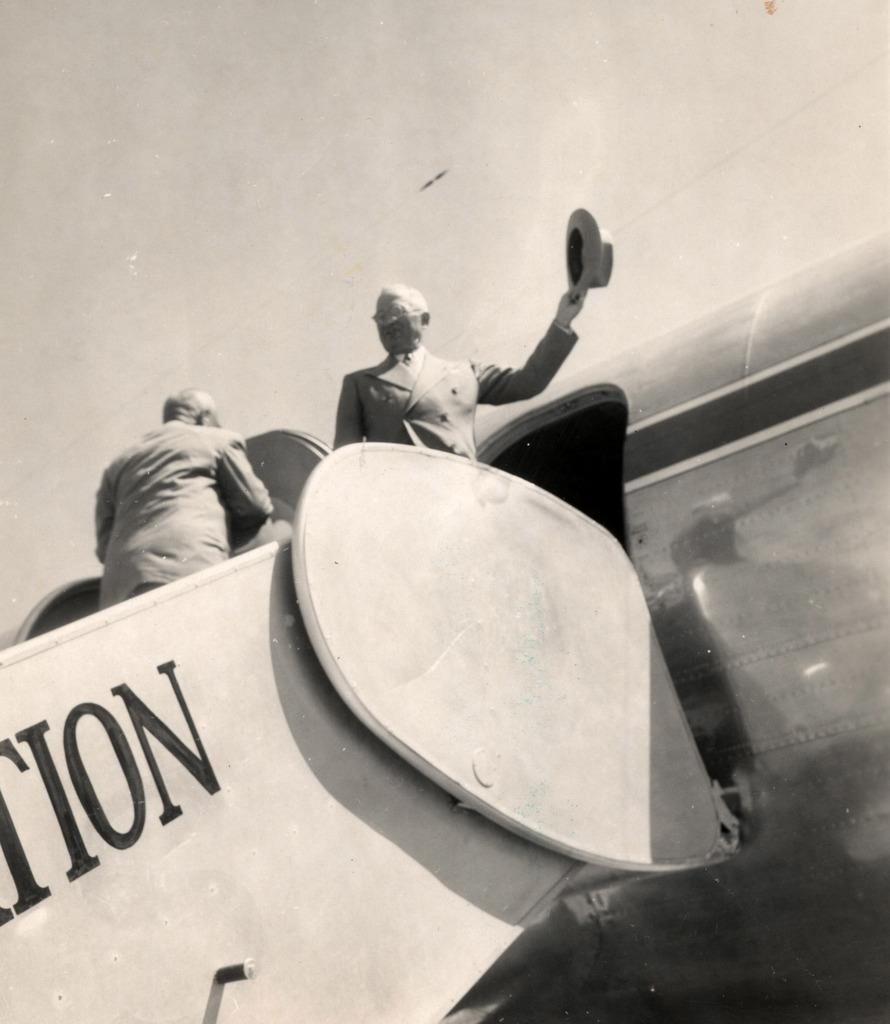How many people are in the image? There are two persons in the image. What are the persons doing in the image? The persons are standing on airplane steps. What is the right side person holding? The right side person is holding a hat. Can you describe any markings or writing on the airplane? Yes, there is writing on the airplane. Is there a cobweb visible on the airplane in the image? There is no mention of a cobweb in the provided facts, and therefore it cannot be determined if one is present in the image. 